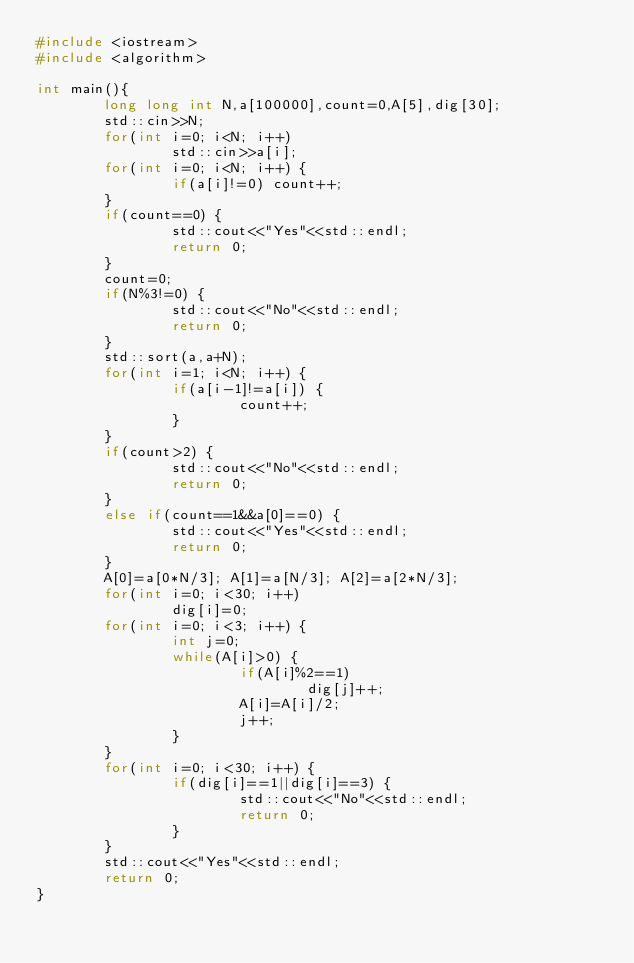<code> <loc_0><loc_0><loc_500><loc_500><_C++_>#include <iostream>
#include <algorithm>

int main(){
        long long int N,a[100000],count=0,A[5],dig[30];
        std::cin>>N;
        for(int i=0; i<N; i++)
                std::cin>>a[i];
        for(int i=0; i<N; i++) {
                if(a[i]!=0) count++;
        }
        if(count==0) {
                std::cout<<"Yes"<<std::endl;
                return 0;
        }
        count=0;
        if(N%3!=0) {
                std::cout<<"No"<<std::endl;
                return 0;
        }
        std::sort(a,a+N);
        for(int i=1; i<N; i++) {
                if(a[i-1]!=a[i]) {
                        count++;
                }
        }
        if(count>2) {
                std::cout<<"No"<<std::endl;
                return 0;
        }
        else if(count==1&&a[0]==0) {
                std::cout<<"Yes"<<std::endl;
                return 0;
        }
        A[0]=a[0*N/3]; A[1]=a[N/3]; A[2]=a[2*N/3];
        for(int i=0; i<30; i++)
                dig[i]=0;
        for(int i=0; i<3; i++) {
                int j=0;
                while(A[i]>0) {
                        if(A[i]%2==1)
                                dig[j]++;
                        A[i]=A[i]/2;
                        j++;
                }
        }
        for(int i=0; i<30; i++) {
                if(dig[i]==1||dig[i]==3) {
                        std::cout<<"No"<<std::endl;
                        return 0;
                }
        }
        std::cout<<"Yes"<<std::endl;
        return 0;
}
</code> 